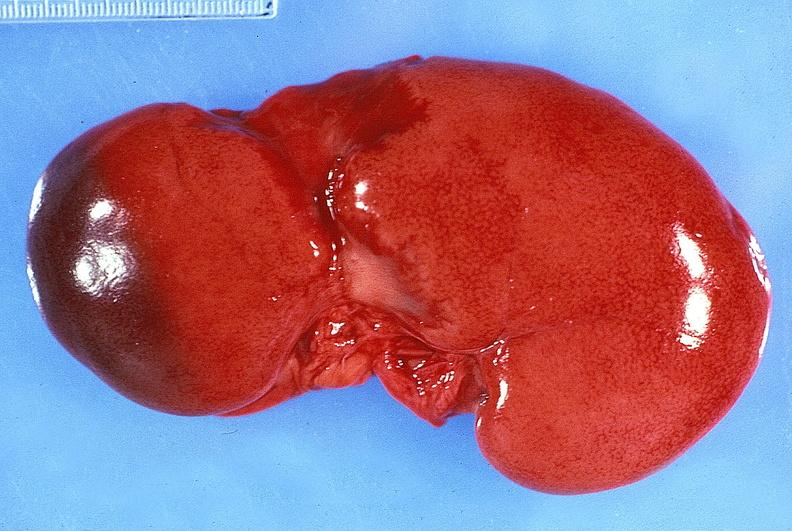what does this image show?
Answer the question using a single word or phrase. Kidney 